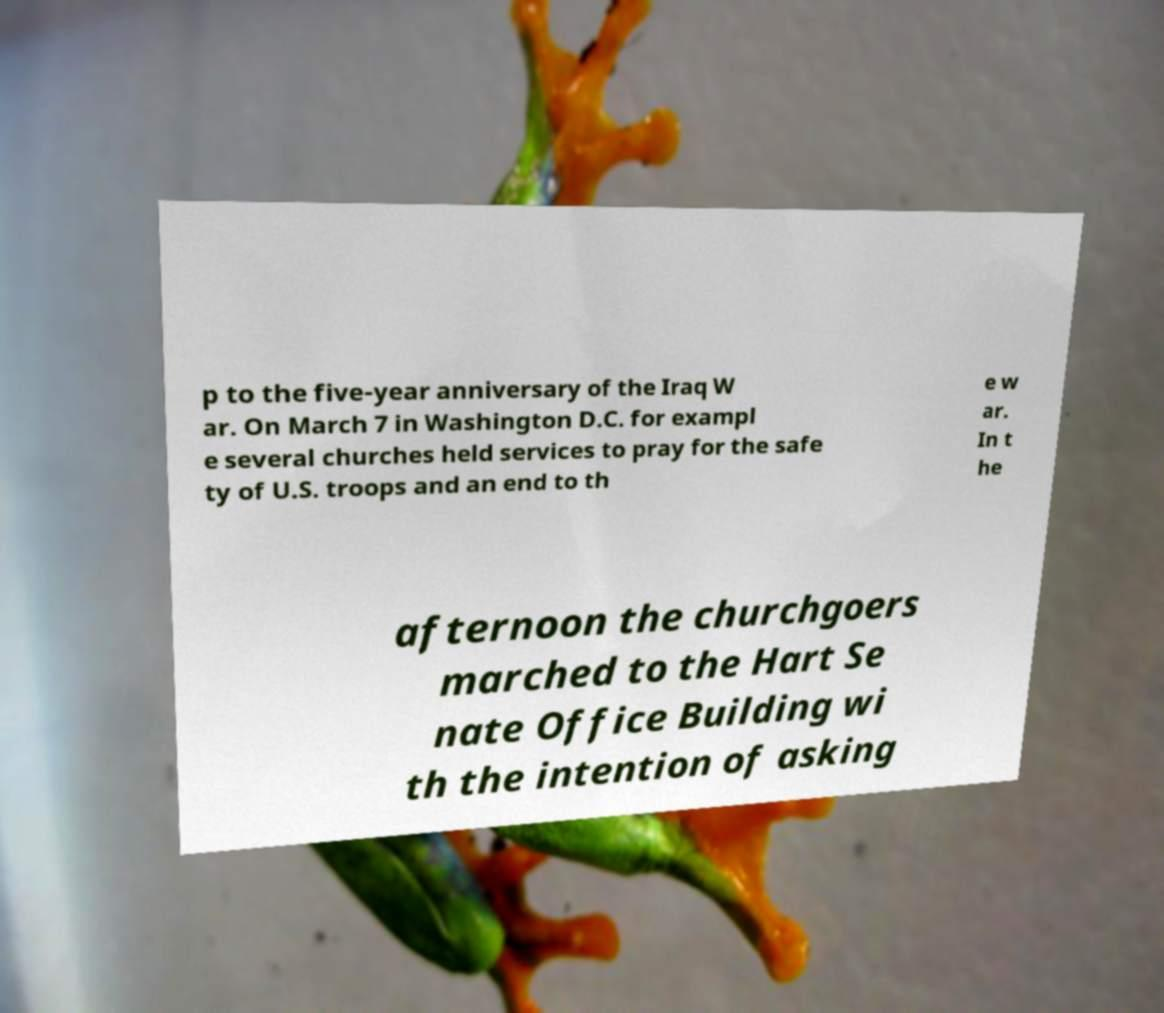What messages or text are displayed in this image? I need them in a readable, typed format. p to the five-year anniversary of the Iraq W ar. On March 7 in Washington D.C. for exampl e several churches held services to pray for the safe ty of U.S. troops and an end to th e w ar. In t he afternoon the churchgoers marched to the Hart Se nate Office Building wi th the intention of asking 